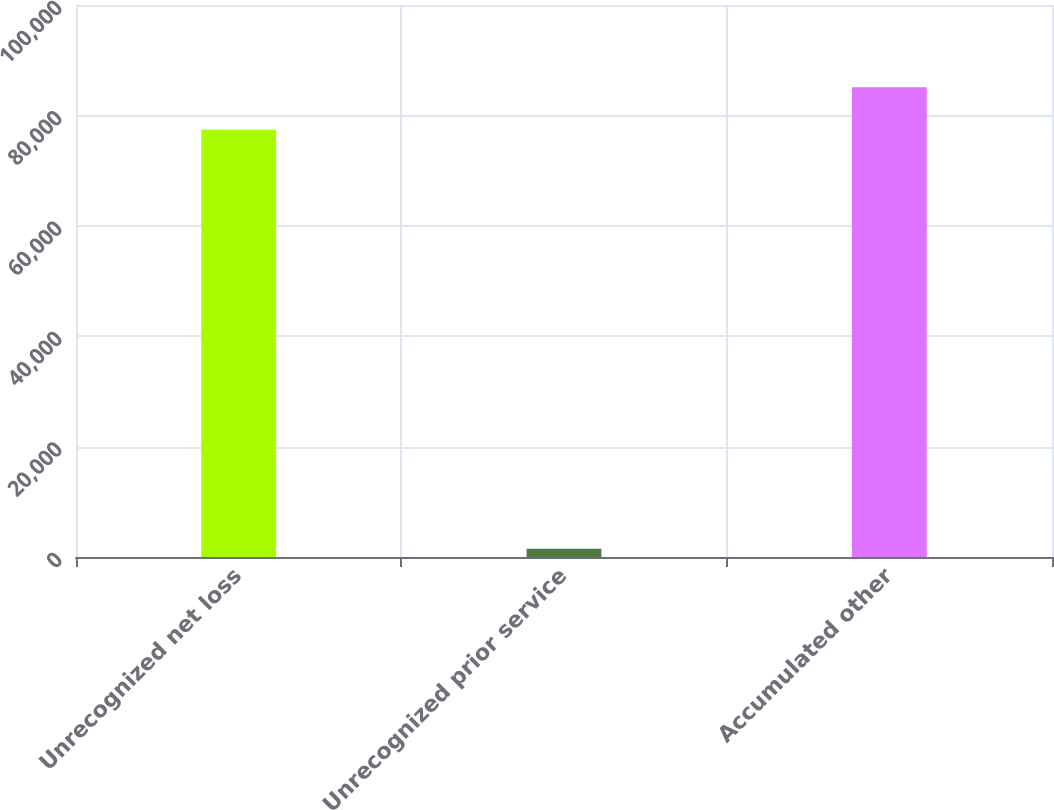Convert chart to OTSL. <chart><loc_0><loc_0><loc_500><loc_500><bar_chart><fcel>Unrecognized net loss<fcel>Unrecognized prior service<fcel>Accumulated other<nl><fcel>77379<fcel>1484<fcel>85116.9<nl></chart> 